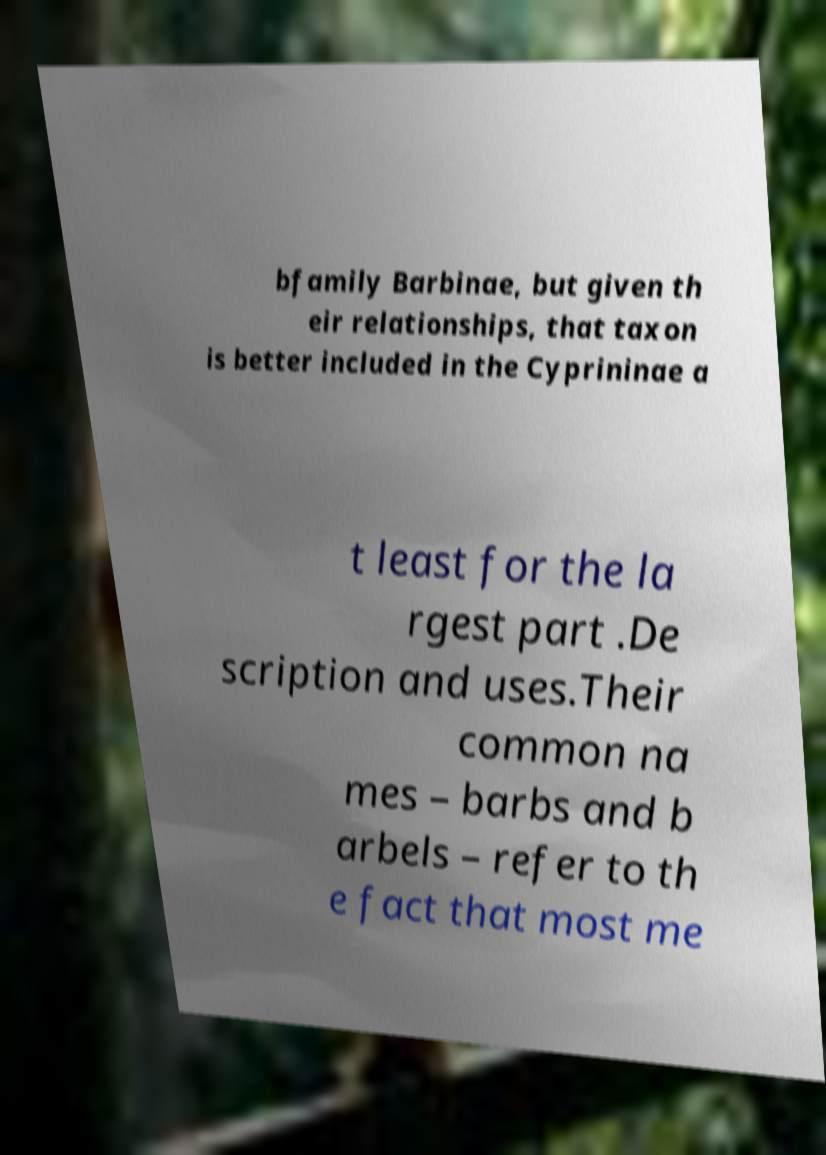Can you accurately transcribe the text from the provided image for me? bfamily Barbinae, but given th eir relationships, that taxon is better included in the Cyprininae a t least for the la rgest part .De scription and uses.Their common na mes – barbs and b arbels – refer to th e fact that most me 